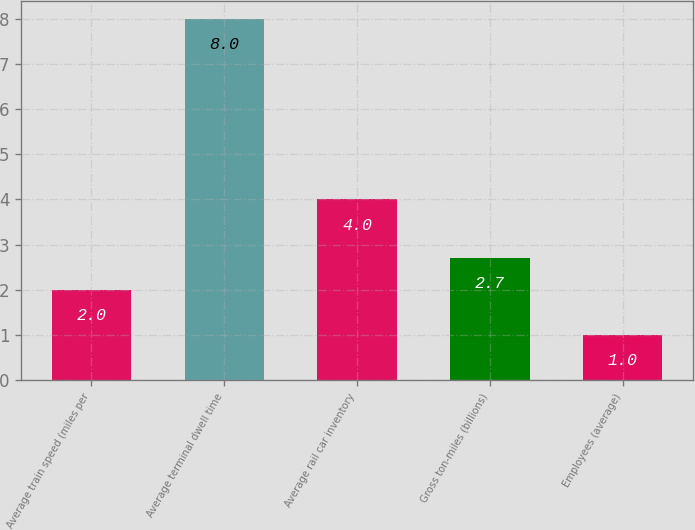Convert chart to OTSL. <chart><loc_0><loc_0><loc_500><loc_500><bar_chart><fcel>Average train speed (miles per<fcel>Average terminal dwell time<fcel>Average rail car inventory<fcel>Gross ton-miles (billions)<fcel>Employees (average)<nl><fcel>2<fcel>8<fcel>4<fcel>2.7<fcel>1<nl></chart> 